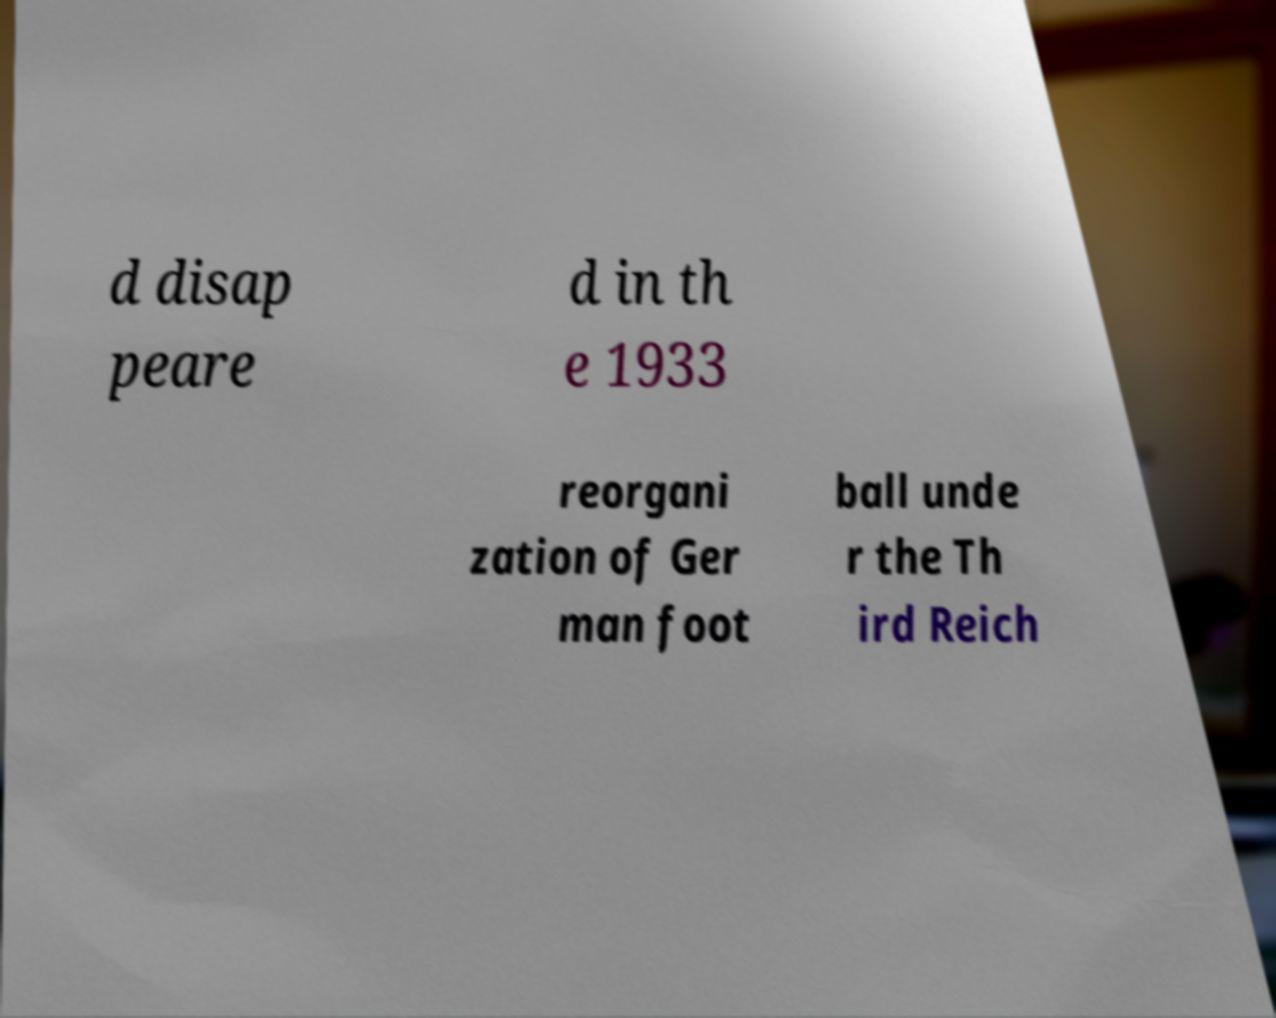Please identify and transcribe the text found in this image. d disap peare d in th e 1933 reorgani zation of Ger man foot ball unde r the Th ird Reich 